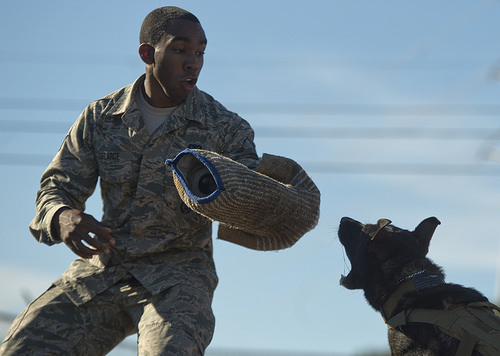<image>
Is there a arm guard behind the man? No. The arm guard is not behind the man. From this viewpoint, the arm guard appears to be positioned elsewhere in the scene. 